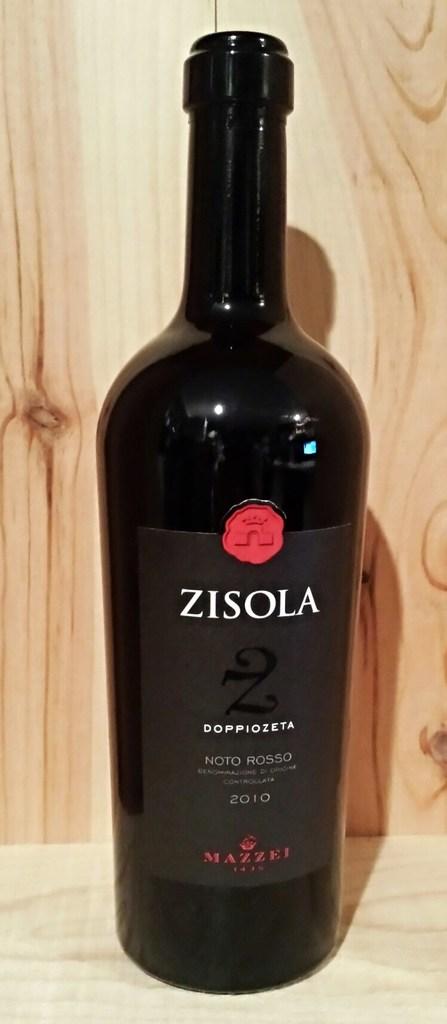What year is the wine?
Your answer should be compact. 2010. What brand of wine is this?
Your answer should be very brief. Zisola. 